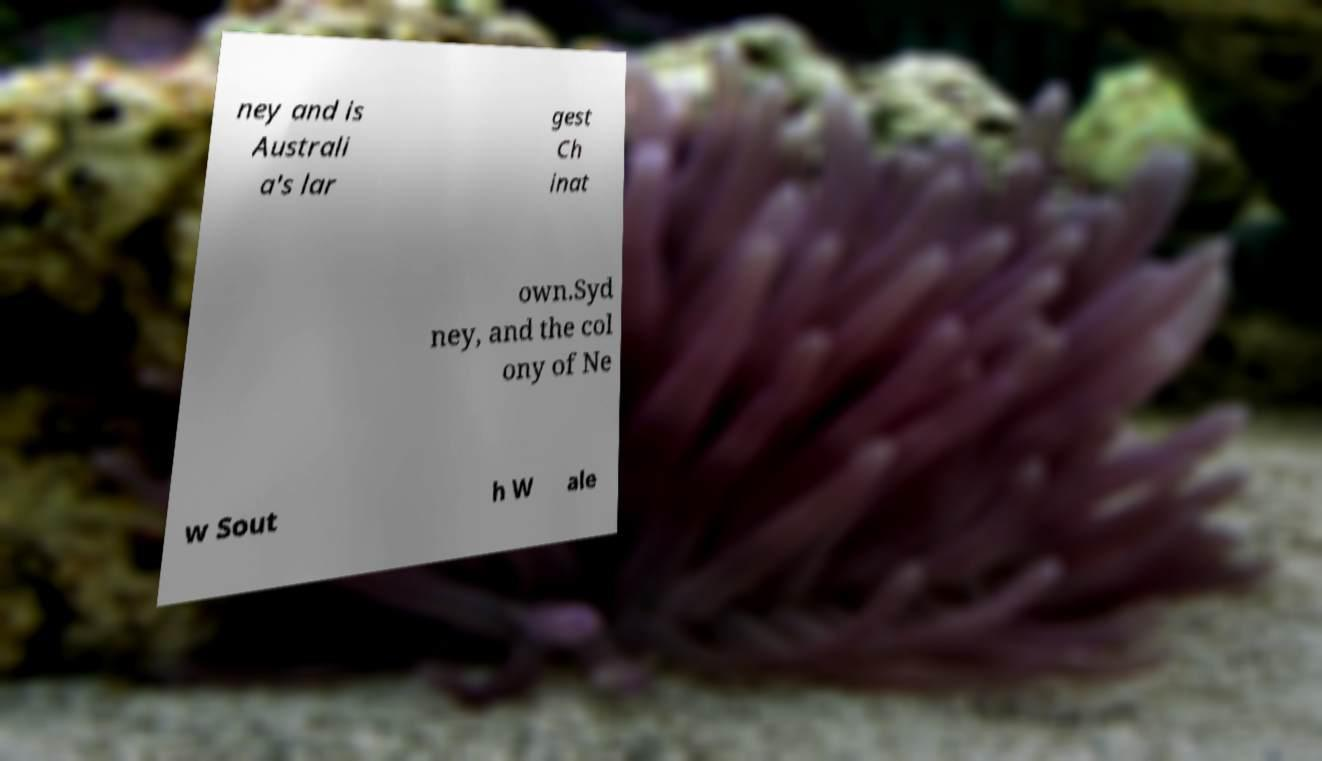Can you read and provide the text displayed in the image?This photo seems to have some interesting text. Can you extract and type it out for me? ney and is Australi a's lar gest Ch inat own.Syd ney, and the col ony of Ne w Sout h W ale 